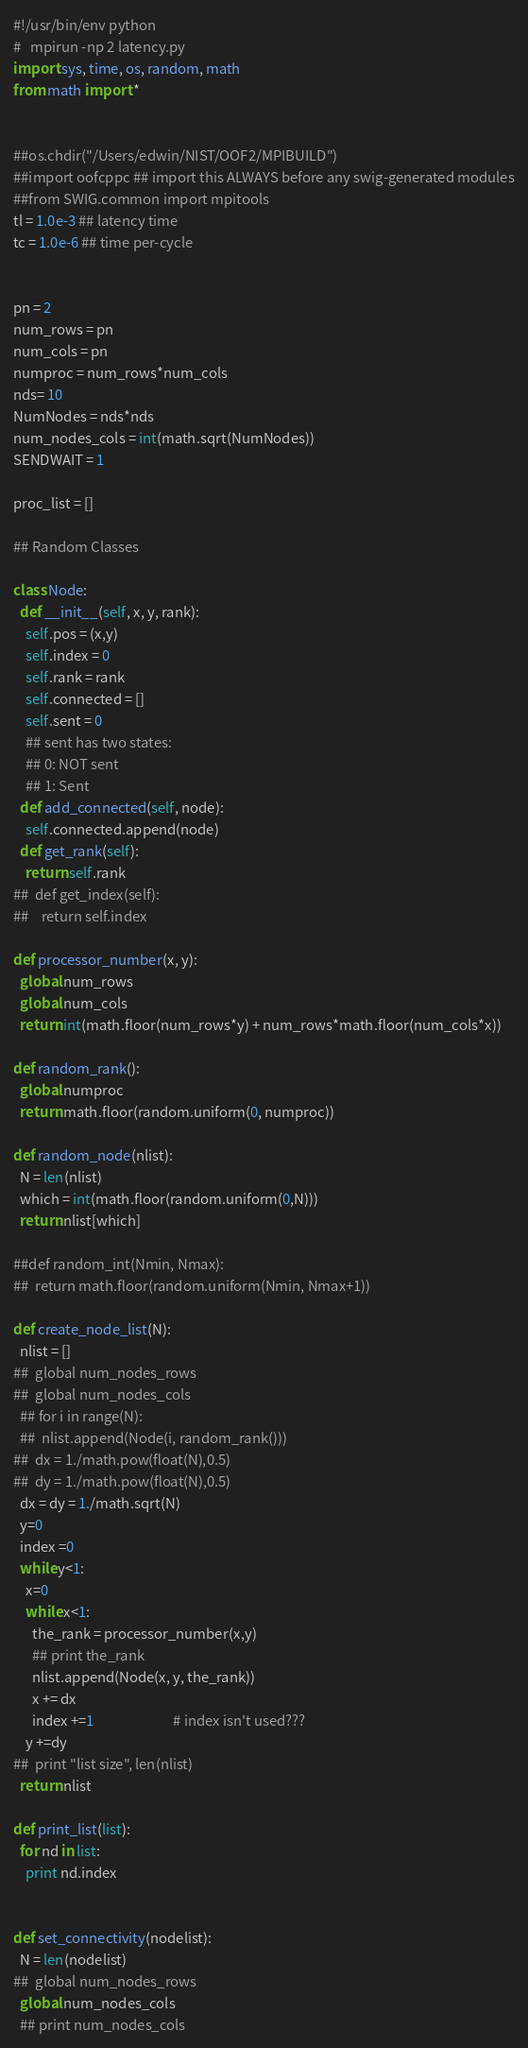<code> <loc_0><loc_0><loc_500><loc_500><_Python_>#!/usr/bin/env python
#   mpirun -np 2 latency.py
import sys, time, os, random, math
from math import *


##os.chdir("/Users/edwin/NIST/OOF2/MPIBUILD")
##import oofcppc ## import this ALWAYS before any swig-generated modules
##from SWIG.common import mpitools
tl = 1.0e-3 ## latency time
tc = 1.0e-6 ## time per-cycle


pn = 2
num_rows = pn
num_cols = pn
numproc = num_rows*num_cols
nds= 10
NumNodes = nds*nds
num_nodes_cols = int(math.sqrt(NumNodes))
SENDWAIT = 1

proc_list = []

## Random Classes

class Node:
  def __init__(self, x, y, rank):
    self.pos = (x,y)
    self.index = 0
    self.rank = rank
    self.connected = []
    self.sent = 0
    ## sent has two states:
    ## 0: NOT sent
    ## 1: Sent 
  def add_connected(self, node):
    self.connected.append(node)
  def get_rank(self):
    return self.rank
##  def get_index(self):
##    return self.index
  
def processor_number(x, y):
  global num_rows
  global num_cols
  return int(math.floor(num_rows*y) + num_rows*math.floor(num_cols*x))

def random_rank():
  global numproc
  return math.floor(random.uniform(0, numproc))

def random_node(nlist):
  N = len(nlist)
  which = int(math.floor(random.uniform(0,N)))
  return nlist[which]

##def random_int(Nmin, Nmax):
##  return math.floor(random.uniform(Nmin, Nmax+1))

def create_node_list(N):
  nlist = []
##  global num_nodes_rows
##  global num_nodes_cols
  ## for i in range(N):
  ##  nlist.append(Node(i, random_rank()))
##  dx = 1./math.pow(float(N),0.5)
##  dy = 1./math.pow(float(N),0.5)
  dx = dy = 1./math.sqrt(N)
  y=0
  index =0
  while y<1:
    x=0
    while x<1:
      the_rank = processor_number(x,y)
      ## print the_rank
      nlist.append(Node(x, y, the_rank))
      x += dx
      index +=1                         # index isn't used???
    y +=dy
##  print "list size", len(nlist)
  return nlist

def print_list(list):
  for nd in list:
    print nd.index


def set_connectivity(nodelist):
  N = len(nodelist)
##  global num_nodes_rows
  global num_nodes_cols
  ## print num_nodes_cols</code> 